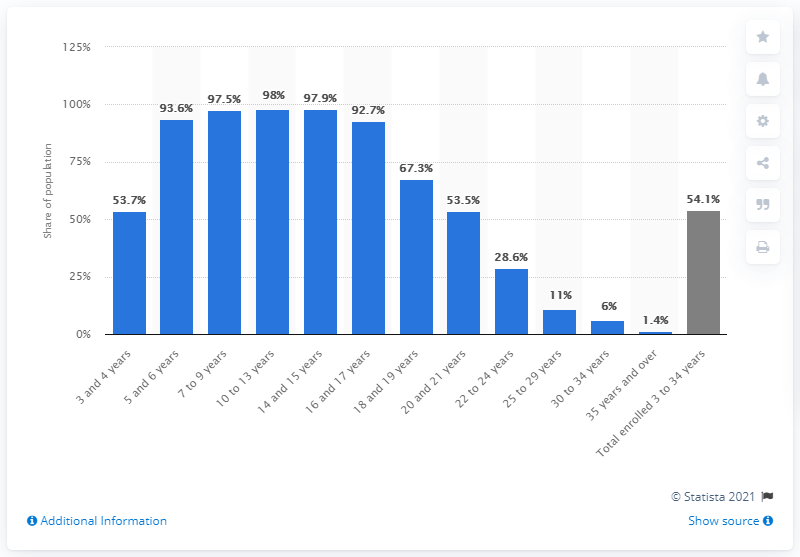Give some essential details in this illustration. In 2019, it was reported that 53.7% of 3 to 4 year olds were enrolled in school. 